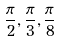Convert formula to latex. <formula><loc_0><loc_0><loc_500><loc_500>\frac { \pi } { 2 } , \frac { \pi } { 3 } , \frac { \pi } { 8 }</formula> 